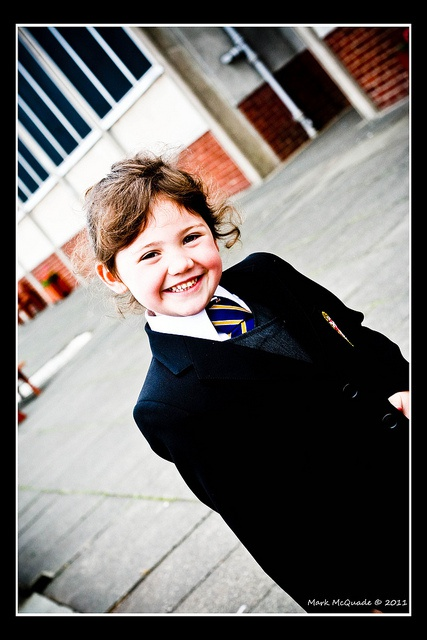Describe the objects in this image and their specific colors. I can see people in black, lightgray, lightpink, and maroon tones and tie in black, navy, darkblue, and lightgray tones in this image. 